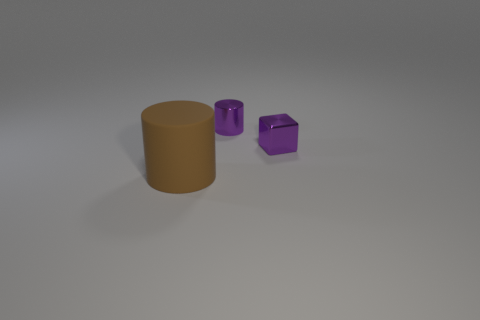How many cylinders have the same color as the tiny metallic cube?
Your response must be concise. 1. What number of other objects are there of the same shape as the brown rubber object?
Ensure brevity in your answer.  1. Does the tiny purple thing in front of the tiny metallic cylinder have the same shape as the thing on the left side of the purple cylinder?
Keep it short and to the point. No. There is a brown thing that is left of the purple thing to the left of the purple metal cube; how many tiny blocks are right of it?
Provide a short and direct response. 1. The big cylinder is what color?
Offer a terse response. Brown. How many other things are the same size as the matte object?
Offer a very short reply. 0. There is another purple thing that is the same shape as the large rubber thing; what is it made of?
Provide a succinct answer. Metal. The object in front of the small metallic thing in front of the cylinder that is behind the large object is made of what material?
Keep it short and to the point. Rubber. What is the size of the purple cylinder that is the same material as the purple block?
Your answer should be very brief. Small. Is there any other thing of the same color as the cube?
Your response must be concise. Yes. 